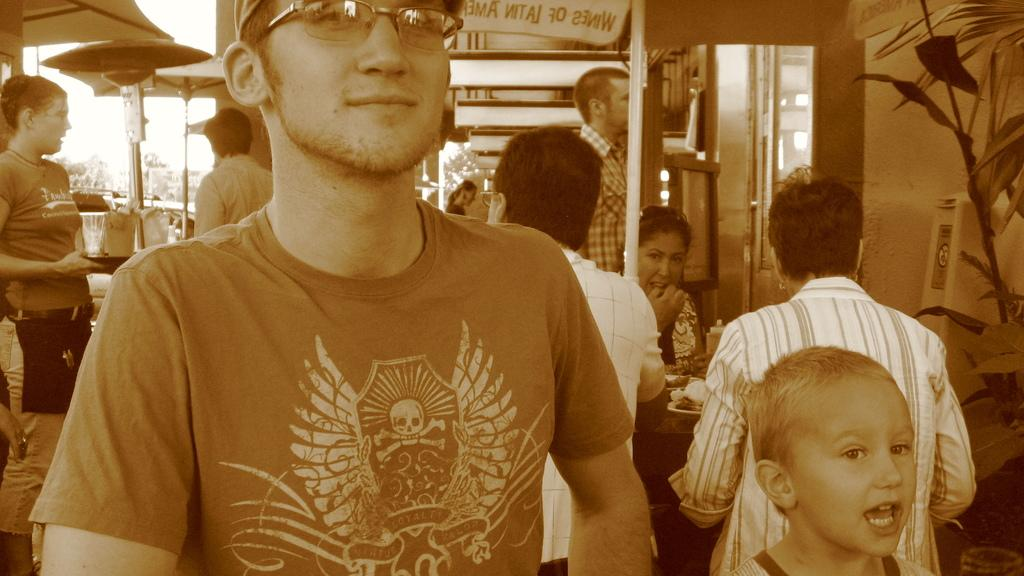Who is present in the image? There is a man in the image. What can be observed about the man's appearance? The man is wearing spectacles and smiling. What can be seen in the background of the image? People, umbrellas, leaves, and other objects are visible in the background of the image. What type of fish can be seen swimming in the image? There are no fish present in the image; it features a man and objects in the background. What type of adjustment is being made to the vessel in the image? There is no vessel or adjustment present in the image. 